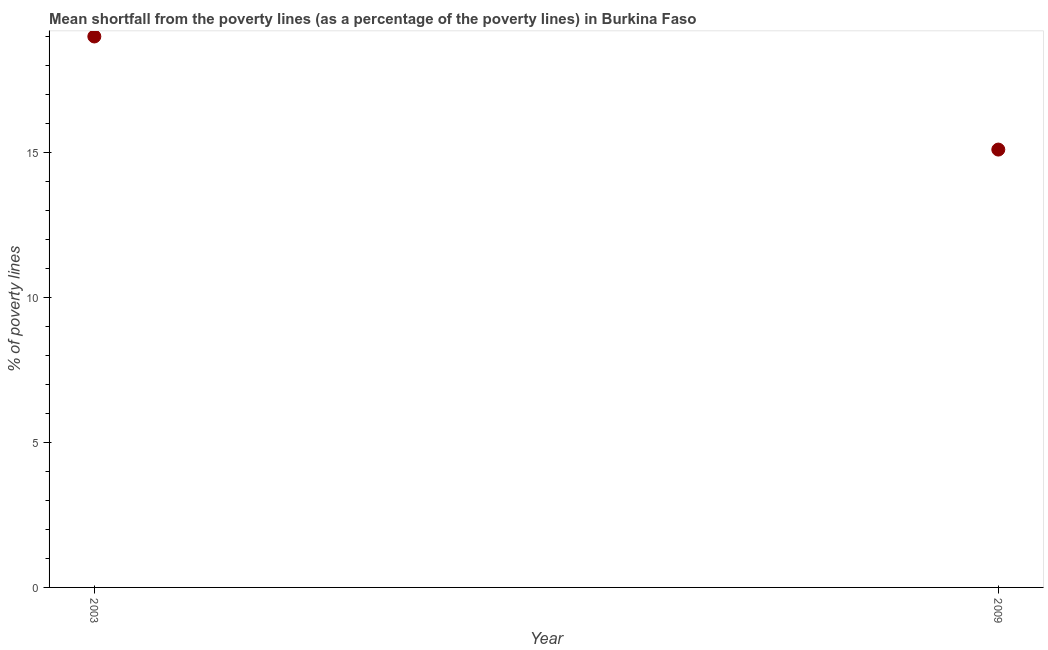What is the poverty gap at national poverty lines in 2003?
Give a very brief answer. 19. Across all years, what is the minimum poverty gap at national poverty lines?
Your answer should be compact. 15.1. In which year was the poverty gap at national poverty lines maximum?
Offer a very short reply. 2003. What is the sum of the poverty gap at national poverty lines?
Make the answer very short. 34.1. What is the difference between the poverty gap at national poverty lines in 2003 and 2009?
Ensure brevity in your answer.  3.9. What is the average poverty gap at national poverty lines per year?
Make the answer very short. 17.05. What is the median poverty gap at national poverty lines?
Give a very brief answer. 17.05. What is the ratio of the poverty gap at national poverty lines in 2003 to that in 2009?
Offer a very short reply. 1.26. Is the poverty gap at national poverty lines in 2003 less than that in 2009?
Provide a succinct answer. No. How many dotlines are there?
Make the answer very short. 1. What is the difference between two consecutive major ticks on the Y-axis?
Provide a succinct answer. 5. What is the title of the graph?
Your answer should be very brief. Mean shortfall from the poverty lines (as a percentage of the poverty lines) in Burkina Faso. What is the label or title of the Y-axis?
Your answer should be compact. % of poverty lines. What is the % of poverty lines in 2003?
Provide a succinct answer. 19. What is the ratio of the % of poverty lines in 2003 to that in 2009?
Ensure brevity in your answer.  1.26. 